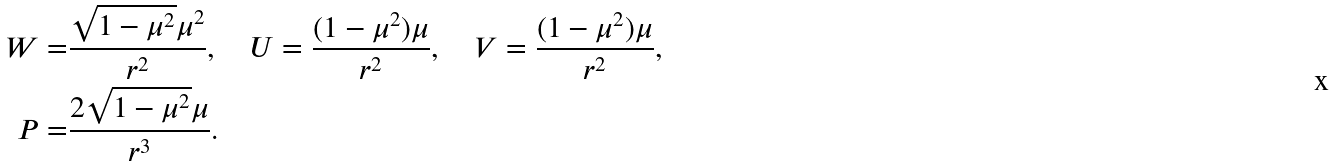<formula> <loc_0><loc_0><loc_500><loc_500>W = & \frac { \sqrt { 1 - \mu ^ { 2 } } \mu ^ { 2 } } { r ^ { 2 } } , \quad U = \frac { ( 1 - \mu ^ { 2 } ) \mu } { r ^ { 2 } } , \quad V = \frac { ( 1 - \mu ^ { 2 } ) \mu } { r ^ { 2 } } , \\ P = & \frac { 2 \sqrt { 1 - \mu ^ { 2 } } \mu } { r ^ { 3 } } .</formula> 